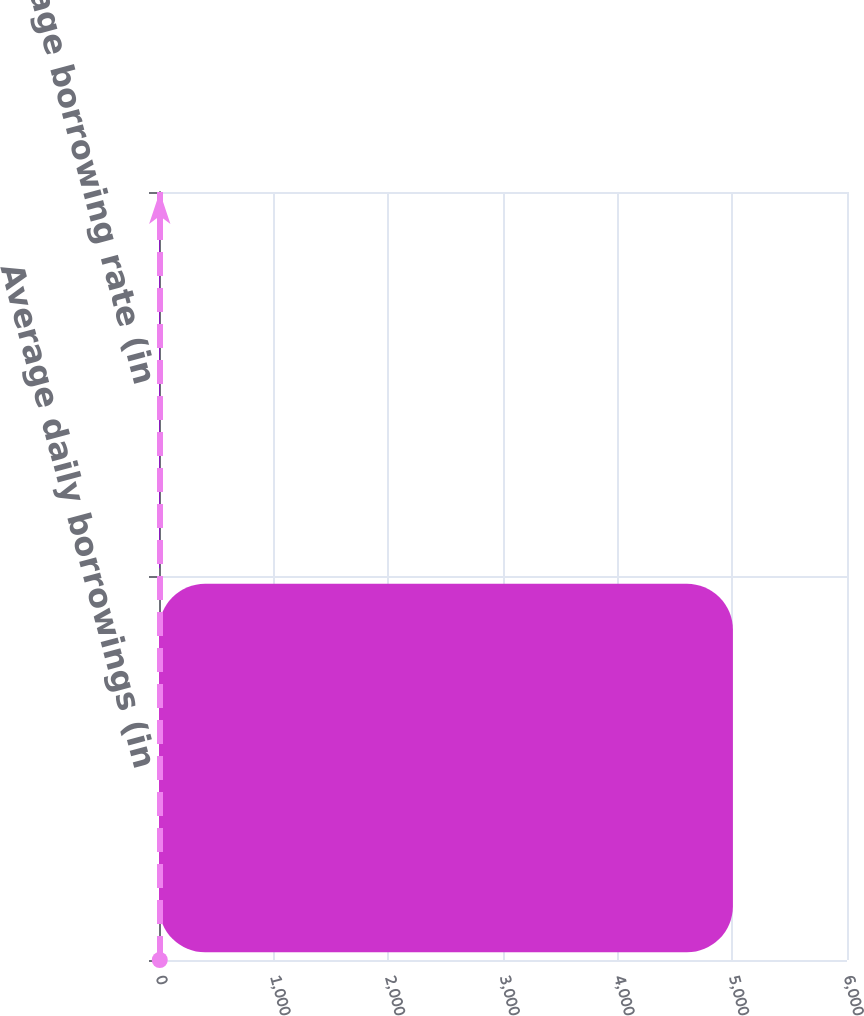Convert chart to OTSL. <chart><loc_0><loc_0><loc_500><loc_500><bar_chart><fcel>Average daily borrowings (in<fcel>Average borrowing rate (in<nl><fcel>5005<fcel>6.7<nl></chart> 